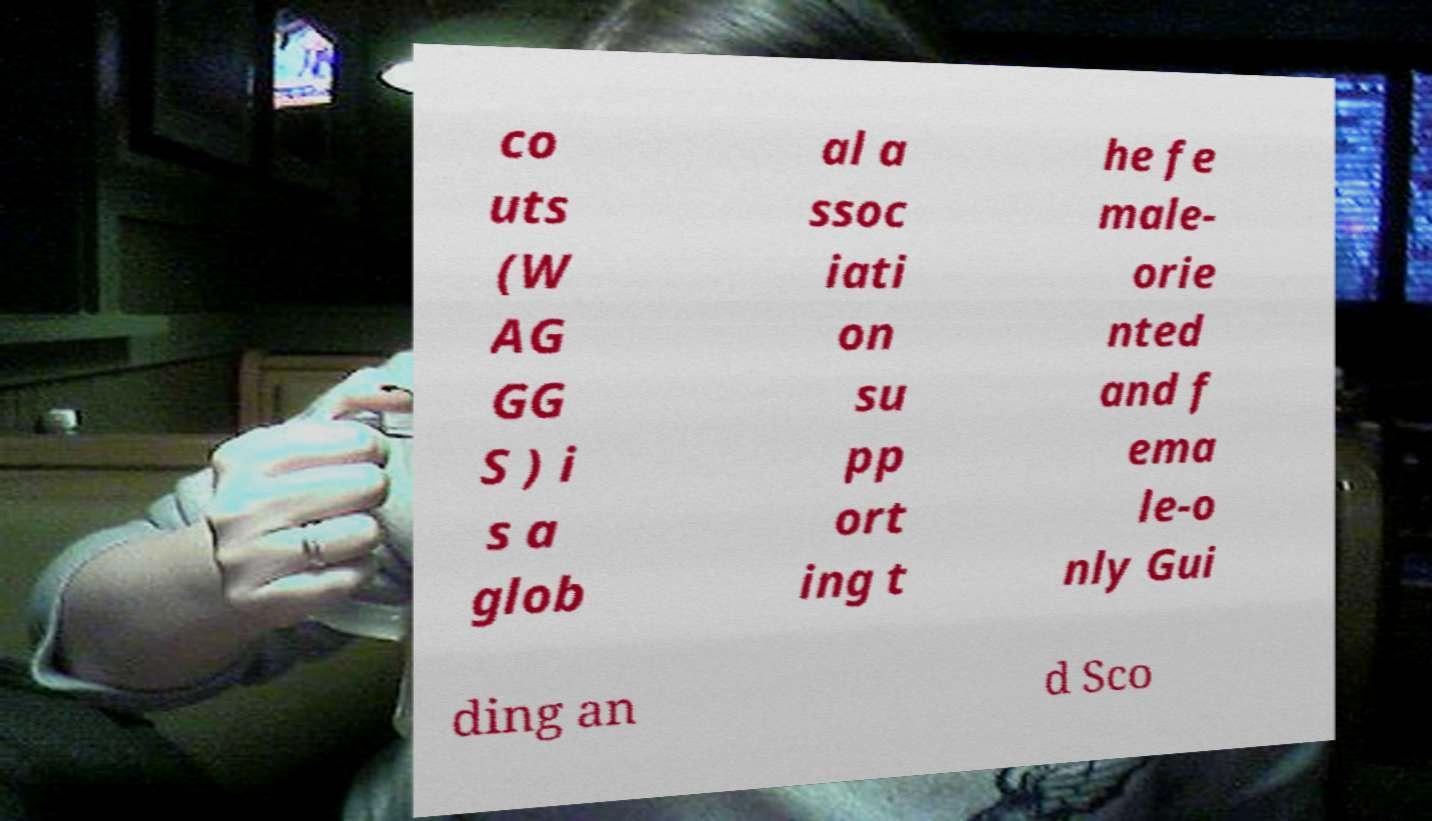Please identify and transcribe the text found in this image. co uts (W AG GG S ) i s a glob al a ssoc iati on su pp ort ing t he fe male- orie nted and f ema le-o nly Gui ding an d Sco 